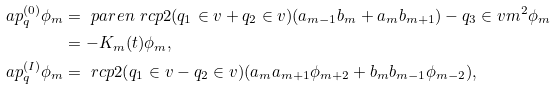Convert formula to latex. <formula><loc_0><loc_0><loc_500><loc_500>\L a p _ { q } ^ { ( 0 ) } \phi _ { m } & = \ p a r e n { \ r c p 2 ( q _ { 1 } \in v + q _ { 2 } \in v ) ( a _ { m - 1 } b _ { m } + a _ { m } b _ { m + 1 } ) - q _ { 3 } \in v m ^ { 2 } } \phi _ { m } \\ & = - K _ { m } ( t ) \phi _ { m } , \\ \L a p _ { q } ^ { ( I ) } \phi _ { m } & = \ r c p 2 ( q _ { 1 } \in v - q _ { 2 } \in v ) ( a _ { m } a _ { m + 1 } \phi _ { m + 2 } + b _ { m } b _ { m - 1 } \phi _ { m - 2 } ) ,</formula> 